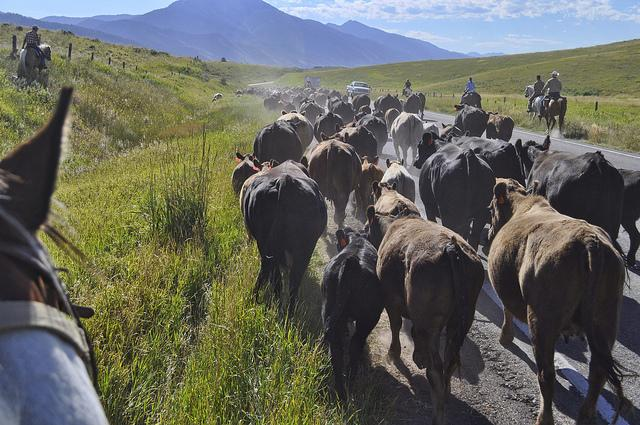What tragedy can happen here? stampede 